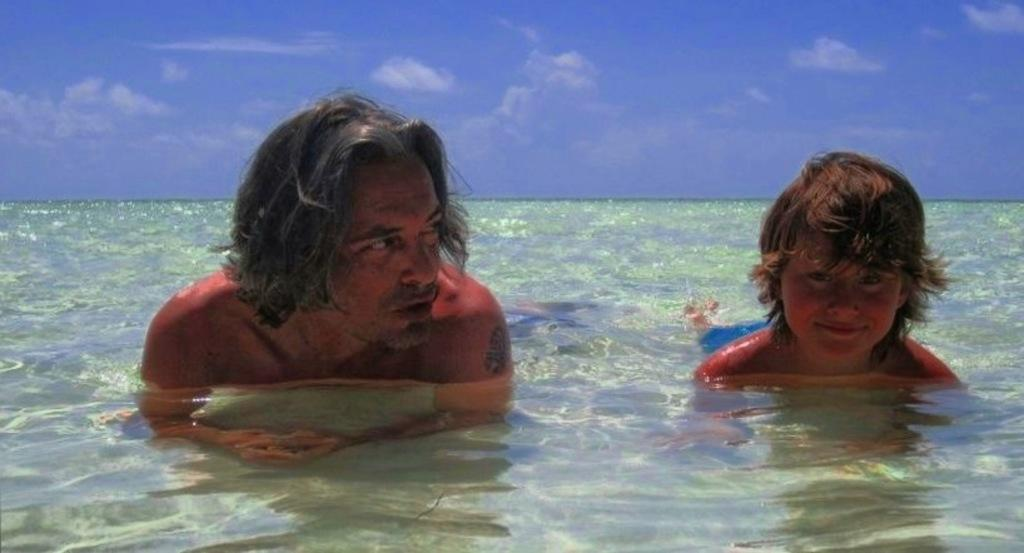Who is present in the image? There is a man and a boy in the image. What are the man and the boy doing in the image? Both the man and the boy are in water. What can be seen in the background of the image? There are clouds and the sky visible in the background of the image. What type of meat is being prepared by the person in the image? There is no person preparing meat in the image; it features a man and a boy in water. What kind of flesh can be seen on the person in the image? There is no person with exposed flesh in the image; both the man and the boy are fully clothed. 